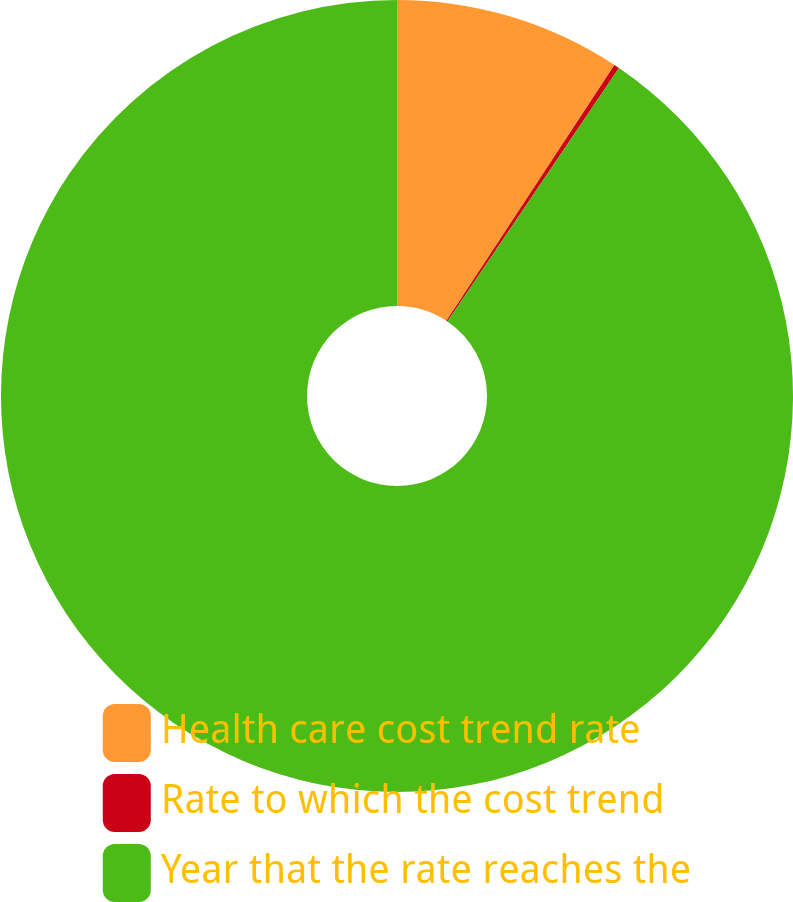<chart> <loc_0><loc_0><loc_500><loc_500><pie_chart><fcel>Health care cost trend rate<fcel>Rate to which the cost trend<fcel>Year that the rate reaches the<nl><fcel>9.25%<fcel>0.22%<fcel>90.52%<nl></chart> 